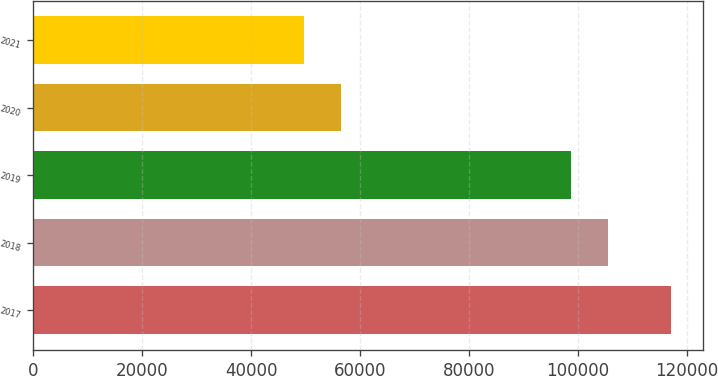Convert chart. <chart><loc_0><loc_0><loc_500><loc_500><bar_chart><fcel>2017<fcel>2018<fcel>2019<fcel>2020<fcel>2021<nl><fcel>117049<fcel>105466<fcel>98734<fcel>56464.6<fcel>49733<nl></chart> 